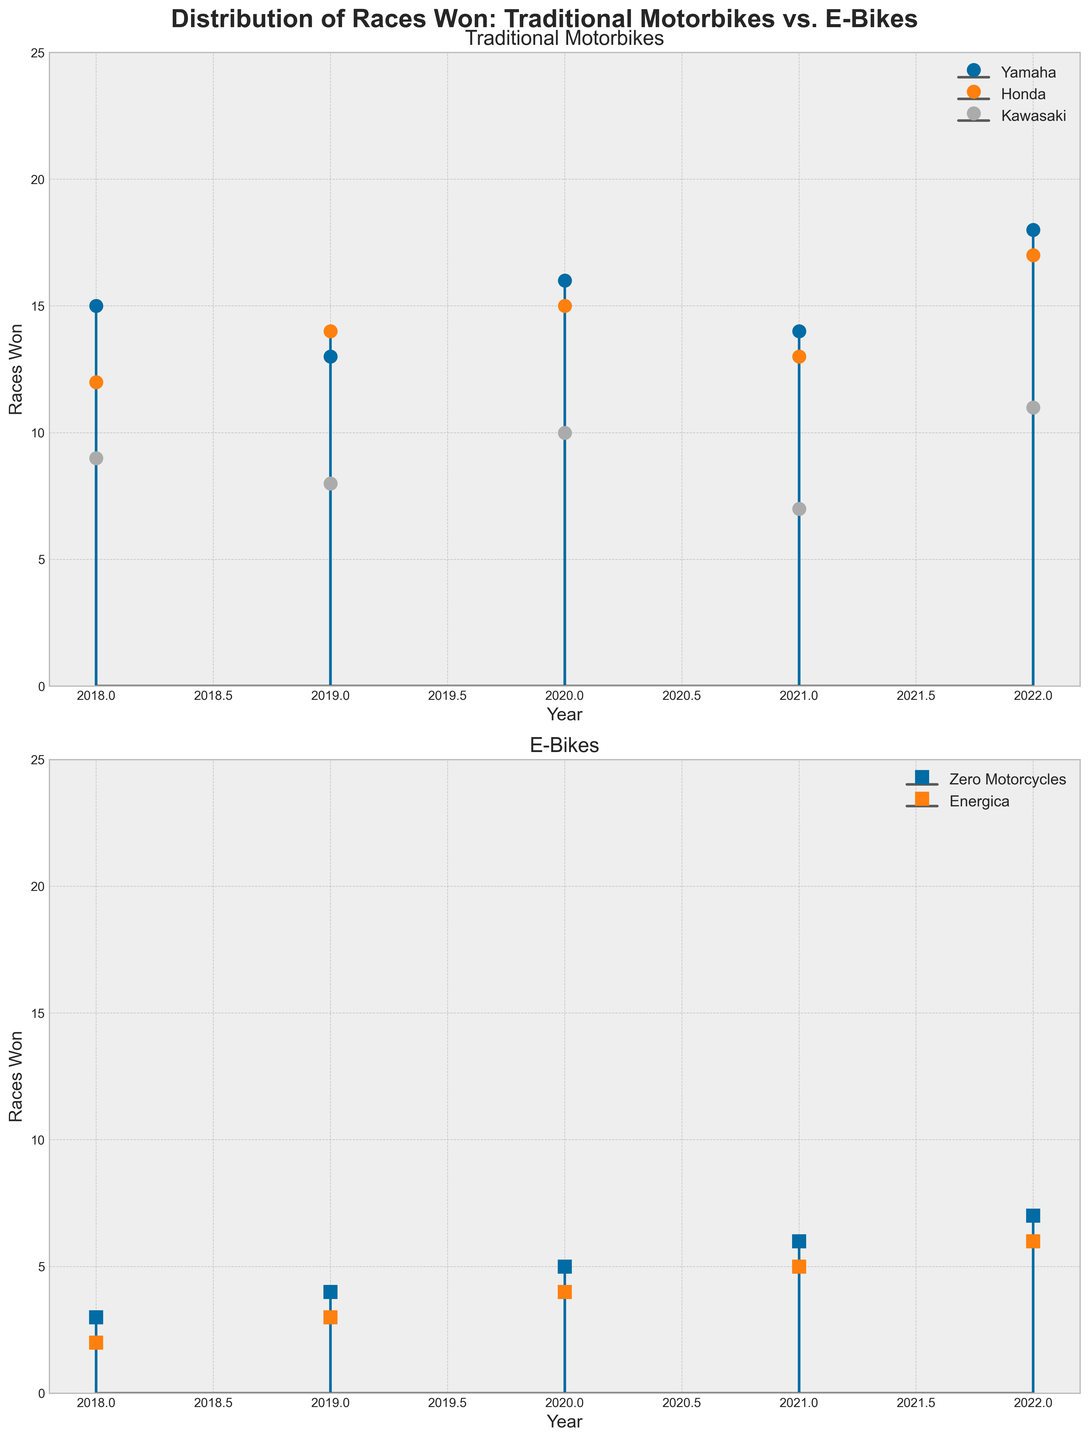What is the title of the figure? The title is displayed at the top of the figure and reads, "Distribution of Races Won: Traditional Motorbikes vs. E-Bikes".
Answer: Distribution of Races Won: Traditional Motorbikes vs. E-Bikes How many races did Yamaha's traditional motorbikes win in total over the five years? By summing up the number of races won by Yamaha for each year from the data points on the Traditional Motorbikes subplot: 15 (2018) + 13 (2019) + 16 (2020) + 14 (2021) + 18 (2022), the total is 76.
Answer: 76 In which year did Zero Motorcycles’ e-bikes win their highest number of races, and how many races were won? By examining the E-Bikes subplot, it is visible that Zero Motorcycles had their highest number of races won in the year 2022, with a total of 7 races.
Answer: 2022, 7 Which traditional motorbike manufacturer had the least number of races won in 2021? In the Traditional Motorbikes subplot for the year 2021, the manufacturer with the smallest number of races won is Kawasaki, with 7 races.
Answer: Kawasaki What is the average number of races won by Honda’s traditional motorbikes per year? Sum the number of races won by Honda's traditional motorbikes over the five years and divide by 5: (12 + 14 + 15 + 13 + 17) / 5. The sum is 71, and the average is 71/5 = 14.2.
Answer: 14.2 Which e-bike manufacturer consistently increased their races won each year? By analyzing the E-Bikes subplot, it is observed that Zero Motorcycles shows an increasing trend, consistently winning more races each year from 2018 to 2022.
Answer: Zero Motorcycles How many more races did Yamaha win than Kawasaki in 2020 for traditional motorbikes? Referencing the Traditional Motorbikes subplot for the year 2020: Yamaha won 16 races, and Kawasaki won 10 races, making Yamaha's win 16 - 10 = 6 races more.
Answer: 6 Which year had the greatest overall number of races won by traditional motorbikes? Sum the races won by all traditional motorbike manufacturers for each year; 2022 has the most with Yamaha (18) + Honda (17) + Kawasaki (11) = 46.
Answer: 2022 Between 2018 and 2022, did Energica ever win the same number of races in any two consecutive years? By examining the E-Bikes subplot, the number of races won by Energica for each year reveals that they did not have the same number in any two consecutive years.
Answer: No 